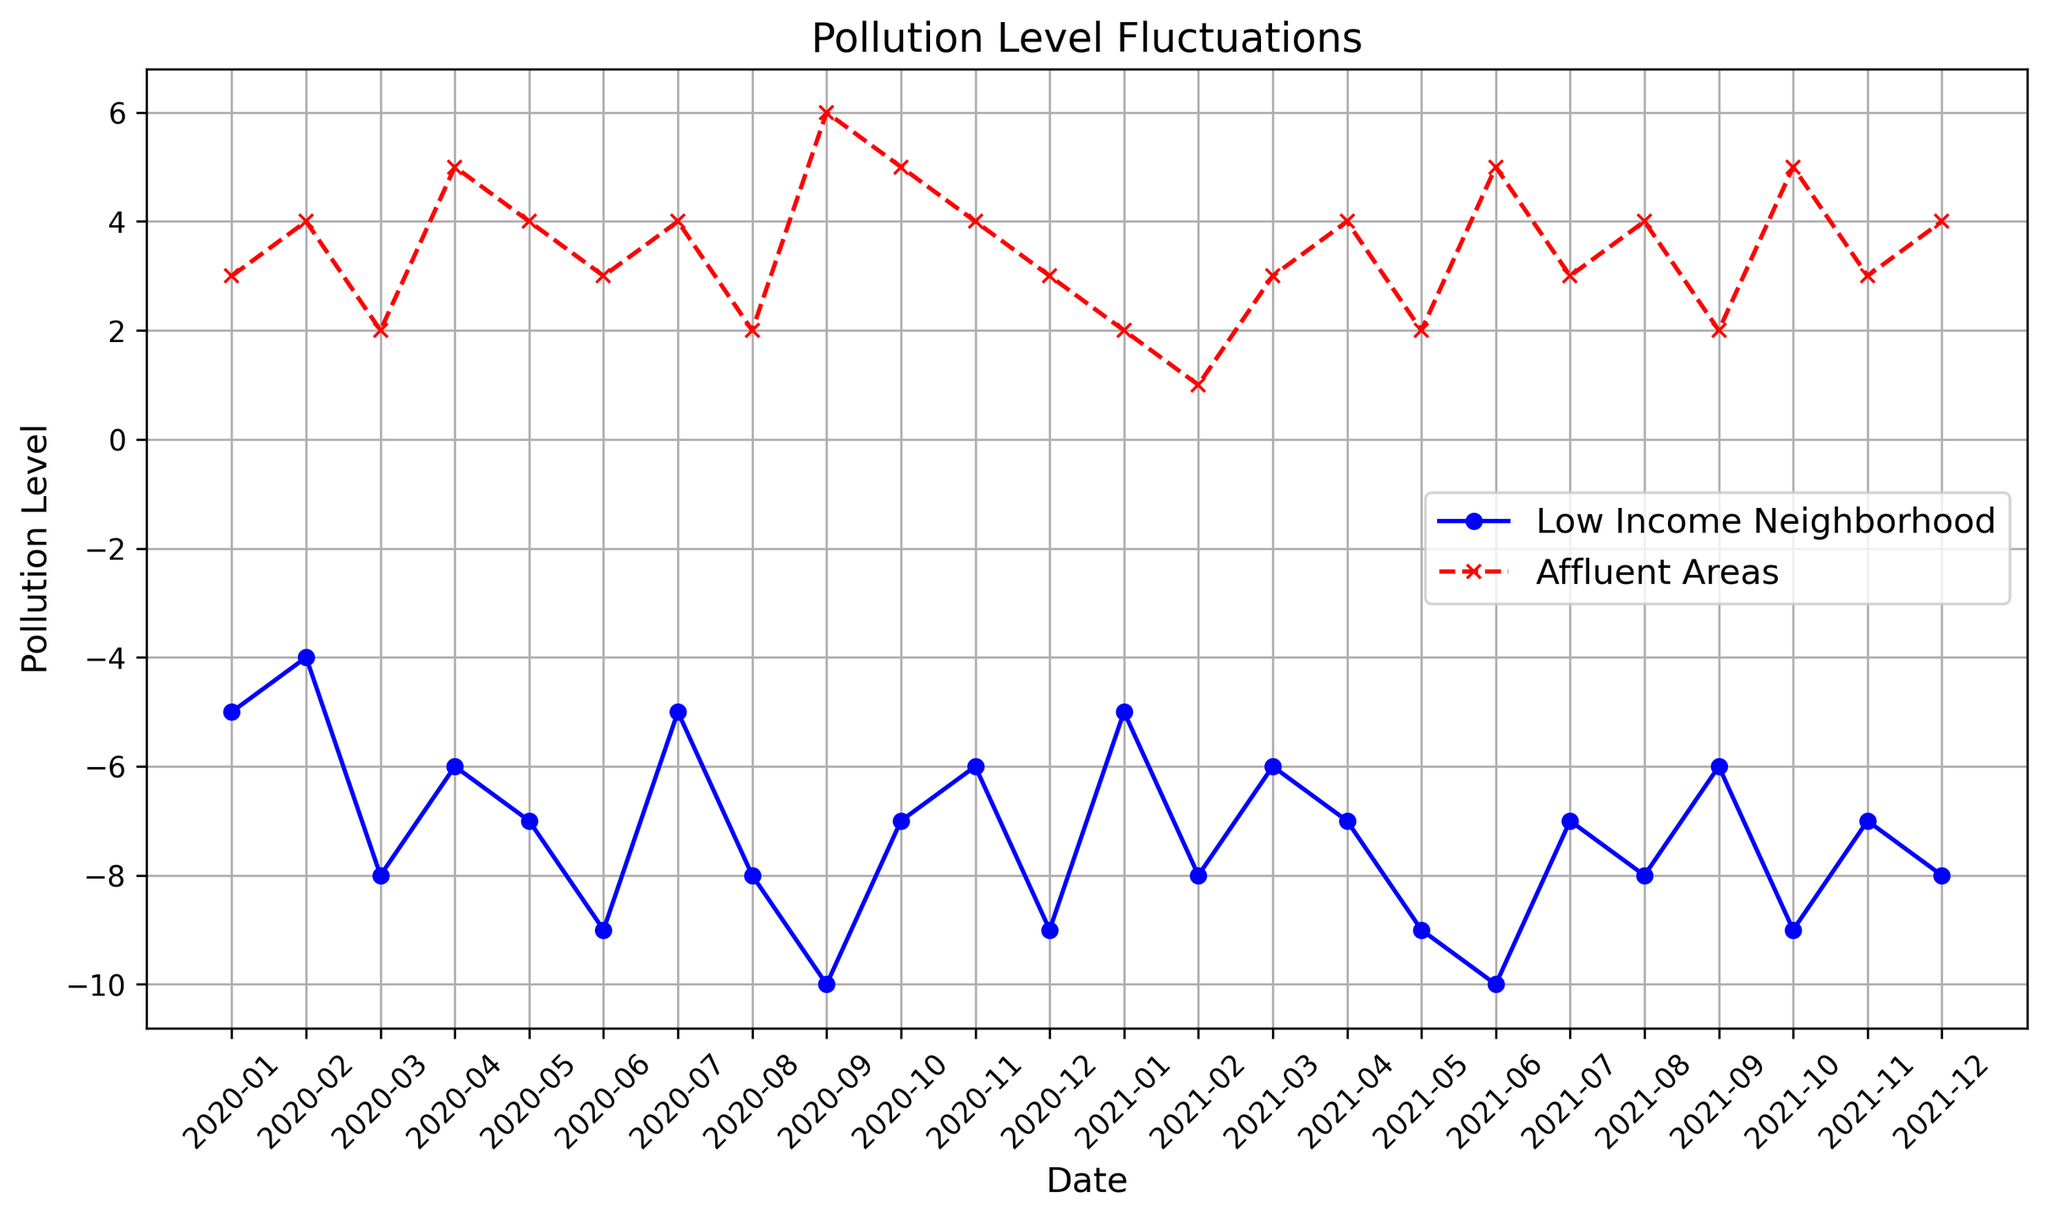What is the highest pollution level recorded for Low-Income Neighborhoods? To determine the highest pollution level for Low-Income Neighborhoods, we look for the least negative number in that data series. The highest value is -5, which occurs in January 2020 and January 2021.
Answer: -5 How does the pollution level in Low-Income Neighborhoods compare to Affluent Areas in March 2020? From the plot, we note the pollution levels for Low-Income Neighborhoods and Affluent Areas in March 2020: -8 and 2 respectively. Comparing these, the pollution level in Low-Income Neighborhoods is significantly lower than in Affluent Areas.
Answer: -8 is less than 2 What month and year did the Affluent Areas record their highest pollution level? To find the highest pollution level in Affluent Areas, we identify the peak in the red line on the plot. The highest point is 6, observed in September 2020.
Answer: September 2020 How much did the pollution level change in Low-Income Neighborhoods from June 2020 to December 2020? To calculate the change, we subtract the pollution level in June 2020 from that in December 2020: (-9) - (-9) = 0. Thus, there is no change.
Answer: 0 What is the average pollution level for Affluent Areas across the entire range? To find the average, sum the pollution levels for each month and divide by the number of months. The pollution levels sum to 77 across 24 months, giving an average of 77/24 ≈ 3.21.
Answer: 3.21 What is the difference in pollution levels between the two areas in April 2021? The pollution levels in April 2021 are -7 for Low-Income Neighborhoods and 4 for Affluent Areas. The difference is 4 - (-7) = 11.
Answer: 11 Which month showed the largest decrease in pollution levels for Low-Income Neighborhoods compared to the previous month? Examining the differences month to month for Low-Income Neighborhoods, the largest decrease is from February 2021 to March 2021, where the pollution level drops from -8 to -6, a change of 2.
Answer: March 2021 Between January 2020 and December 2021, in how many months were pollution levels equal between Low-Income Neighborhoods and Affluent Areas? From visual inspection, there are no months where the pollution levels in Low-Income Neighborhoods and Affluent Areas are the same.
Answer: 0 What trend do you notice in pollution levels in Affluent Areas from January 2020 to December 2021? From the plotted data, pollution levels fluctuate but generally remain higher and more stable compared to Low-Income Neighborhoods. The data shows regular rises and falls but trends towards higher pollution levels.
Answer: Fluctuating but relatively stable and higher Which neighborhood consistently shows more negative pollution levels throughout the time frame? Over the entire period, the Low-Income Neighborhood consistently shows more negative (lower) pollution levels compared to Affluent Areas, reflected in the blue line staying below the red line.
Answer: Low-Income Neighborhood 